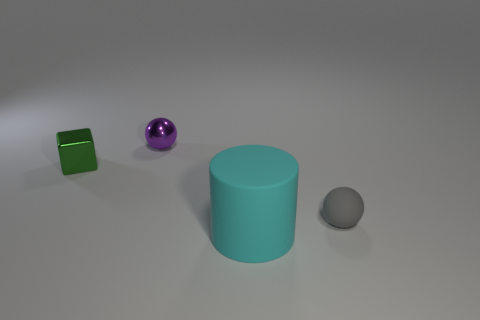How many things are tiny yellow metal balls or green metal objects?
Offer a terse response. 1. What color is the small sphere that is to the right of the cyan rubber cylinder?
Give a very brief answer. Gray. Is the number of matte cylinders that are behind the purple ball less than the number of purple spheres?
Offer a very short reply. Yes. Are there any other things that are the same size as the cyan thing?
Make the answer very short. No. Is the big cyan cylinder made of the same material as the purple thing?
Give a very brief answer. No. How many objects are tiny objects on the left side of the large rubber cylinder or spheres that are left of the tiny gray rubber thing?
Your answer should be very brief. 2. Is there a matte cylinder that has the same size as the gray object?
Ensure brevity in your answer.  No. There is a tiny matte thing that is the same shape as the tiny purple shiny object; what is its color?
Provide a succinct answer. Gray. There is a object right of the cyan object; are there any rubber cylinders that are left of it?
Make the answer very short. Yes. There is a tiny thing behind the tiny green shiny cube; does it have the same shape as the gray thing?
Give a very brief answer. Yes. 